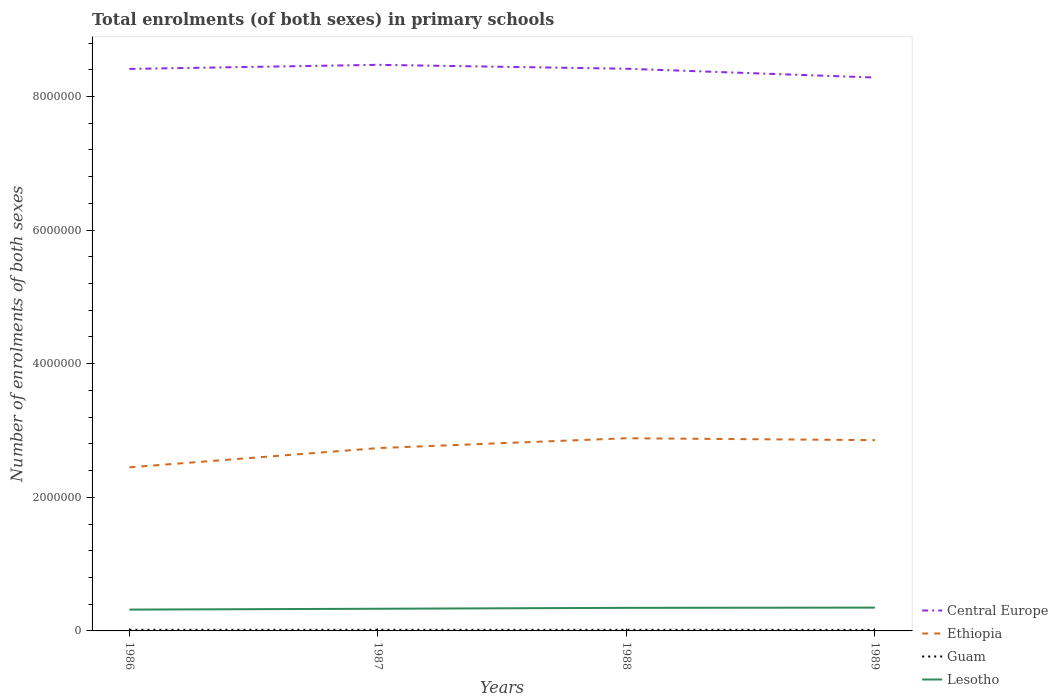Across all years, what is the maximum number of enrolments in primary schools in Lesotho?
Your response must be concise. 3.19e+05. What is the total number of enrolments in primary schools in Ethiopia in the graph?
Your response must be concise. -1.48e+05. What is the difference between the highest and the second highest number of enrolments in primary schools in Guam?
Your answer should be compact. 1267. What is the difference between the highest and the lowest number of enrolments in primary schools in Lesotho?
Your answer should be very brief. 2. How many years are there in the graph?
Ensure brevity in your answer.  4. What is the difference between two consecutive major ticks on the Y-axis?
Your answer should be compact. 2.00e+06. Are the values on the major ticks of Y-axis written in scientific E-notation?
Keep it short and to the point. No. Does the graph contain grids?
Give a very brief answer. No. How many legend labels are there?
Your answer should be compact. 4. What is the title of the graph?
Keep it short and to the point. Total enrolments (of both sexes) in primary schools. What is the label or title of the X-axis?
Ensure brevity in your answer.  Years. What is the label or title of the Y-axis?
Offer a very short reply. Number of enrolments of both sexes. What is the Number of enrolments of both sexes in Central Europe in 1986?
Offer a terse response. 8.41e+06. What is the Number of enrolments of both sexes in Ethiopia in 1986?
Give a very brief answer. 2.45e+06. What is the Number of enrolments of both sexes in Guam in 1986?
Make the answer very short. 1.68e+04. What is the Number of enrolments of both sexes of Lesotho in 1986?
Make the answer very short. 3.19e+05. What is the Number of enrolments of both sexes of Central Europe in 1987?
Provide a succinct answer. 8.47e+06. What is the Number of enrolments of both sexes of Ethiopia in 1987?
Make the answer very short. 2.74e+06. What is the Number of enrolments of both sexes in Guam in 1987?
Your answer should be very brief. 1.67e+04. What is the Number of enrolments of both sexes in Lesotho in 1987?
Offer a very short reply. 3.32e+05. What is the Number of enrolments of both sexes in Central Europe in 1988?
Your answer should be very brief. 8.41e+06. What is the Number of enrolments of both sexes of Ethiopia in 1988?
Make the answer very short. 2.88e+06. What is the Number of enrolments of both sexes in Guam in 1988?
Provide a short and direct response. 1.67e+04. What is the Number of enrolments of both sexes of Lesotho in 1988?
Your answer should be compact. 3.46e+05. What is the Number of enrolments of both sexes of Central Europe in 1989?
Offer a terse response. 8.28e+06. What is the Number of enrolments of both sexes in Ethiopia in 1989?
Make the answer very short. 2.86e+06. What is the Number of enrolments of both sexes of Guam in 1989?
Provide a succinct answer. 1.55e+04. What is the Number of enrolments of both sexes of Lesotho in 1989?
Your response must be concise. 3.49e+05. Across all years, what is the maximum Number of enrolments of both sexes of Central Europe?
Ensure brevity in your answer.  8.47e+06. Across all years, what is the maximum Number of enrolments of both sexes of Ethiopia?
Keep it short and to the point. 2.88e+06. Across all years, what is the maximum Number of enrolments of both sexes of Guam?
Your answer should be very brief. 1.68e+04. Across all years, what is the maximum Number of enrolments of both sexes of Lesotho?
Keep it short and to the point. 3.49e+05. Across all years, what is the minimum Number of enrolments of both sexes of Central Europe?
Offer a terse response. 8.28e+06. Across all years, what is the minimum Number of enrolments of both sexes of Ethiopia?
Keep it short and to the point. 2.45e+06. Across all years, what is the minimum Number of enrolments of both sexes of Guam?
Your answer should be compact. 1.55e+04. Across all years, what is the minimum Number of enrolments of both sexes in Lesotho?
Offer a terse response. 3.19e+05. What is the total Number of enrolments of both sexes in Central Europe in the graph?
Ensure brevity in your answer.  3.36e+07. What is the total Number of enrolments of both sexes in Ethiopia in the graph?
Make the answer very short. 1.09e+07. What is the total Number of enrolments of both sexes in Guam in the graph?
Ensure brevity in your answer.  6.57e+04. What is the total Number of enrolments of both sexes in Lesotho in the graph?
Offer a very short reply. 1.35e+06. What is the difference between the Number of enrolments of both sexes of Central Europe in 1986 and that in 1987?
Your answer should be compact. -6.10e+04. What is the difference between the Number of enrolments of both sexes in Ethiopia in 1986 and that in 1987?
Your answer should be very brief. -2.88e+05. What is the difference between the Number of enrolments of both sexes of Guam in 1986 and that in 1987?
Make the answer very short. 50. What is the difference between the Number of enrolments of both sexes of Lesotho in 1986 and that in 1987?
Your response must be concise. -1.27e+04. What is the difference between the Number of enrolments of both sexes of Central Europe in 1986 and that in 1988?
Give a very brief answer. -2541. What is the difference between the Number of enrolments of both sexes of Ethiopia in 1986 and that in 1988?
Provide a succinct answer. -4.35e+05. What is the difference between the Number of enrolments of both sexes of Guam in 1986 and that in 1988?
Provide a succinct answer. 123. What is the difference between the Number of enrolments of both sexes in Lesotho in 1986 and that in 1988?
Provide a short and direct response. -2.64e+04. What is the difference between the Number of enrolments of both sexes of Central Europe in 1986 and that in 1989?
Ensure brevity in your answer.  1.29e+05. What is the difference between the Number of enrolments of both sexes of Ethiopia in 1986 and that in 1989?
Provide a short and direct response. -4.07e+05. What is the difference between the Number of enrolments of both sexes in Guam in 1986 and that in 1989?
Offer a very short reply. 1267. What is the difference between the Number of enrolments of both sexes in Lesotho in 1986 and that in 1989?
Keep it short and to the point. -2.97e+04. What is the difference between the Number of enrolments of both sexes of Central Europe in 1987 and that in 1988?
Ensure brevity in your answer.  5.85e+04. What is the difference between the Number of enrolments of both sexes of Ethiopia in 1987 and that in 1988?
Your response must be concise. -1.48e+05. What is the difference between the Number of enrolments of both sexes in Lesotho in 1987 and that in 1988?
Your answer should be compact. -1.37e+04. What is the difference between the Number of enrolments of both sexes in Central Europe in 1987 and that in 1989?
Your response must be concise. 1.90e+05. What is the difference between the Number of enrolments of both sexes in Ethiopia in 1987 and that in 1989?
Provide a short and direct response. -1.19e+05. What is the difference between the Number of enrolments of both sexes in Guam in 1987 and that in 1989?
Your answer should be compact. 1217. What is the difference between the Number of enrolments of both sexes in Lesotho in 1987 and that in 1989?
Your answer should be very brief. -1.70e+04. What is the difference between the Number of enrolments of both sexes in Central Europe in 1988 and that in 1989?
Offer a very short reply. 1.32e+05. What is the difference between the Number of enrolments of both sexes of Ethiopia in 1988 and that in 1989?
Ensure brevity in your answer.  2.82e+04. What is the difference between the Number of enrolments of both sexes in Guam in 1988 and that in 1989?
Give a very brief answer. 1144. What is the difference between the Number of enrolments of both sexes in Lesotho in 1988 and that in 1989?
Provide a short and direct response. -3294. What is the difference between the Number of enrolments of both sexes of Central Europe in 1986 and the Number of enrolments of both sexes of Ethiopia in 1987?
Provide a succinct answer. 5.68e+06. What is the difference between the Number of enrolments of both sexes in Central Europe in 1986 and the Number of enrolments of both sexes in Guam in 1987?
Keep it short and to the point. 8.40e+06. What is the difference between the Number of enrolments of both sexes of Central Europe in 1986 and the Number of enrolments of both sexes of Lesotho in 1987?
Your answer should be compact. 8.08e+06. What is the difference between the Number of enrolments of both sexes in Ethiopia in 1986 and the Number of enrolments of both sexes in Guam in 1987?
Give a very brief answer. 2.43e+06. What is the difference between the Number of enrolments of both sexes in Ethiopia in 1986 and the Number of enrolments of both sexes in Lesotho in 1987?
Your response must be concise. 2.12e+06. What is the difference between the Number of enrolments of both sexes of Guam in 1986 and the Number of enrolments of both sexes of Lesotho in 1987?
Make the answer very short. -3.15e+05. What is the difference between the Number of enrolments of both sexes in Central Europe in 1986 and the Number of enrolments of both sexes in Ethiopia in 1988?
Offer a terse response. 5.53e+06. What is the difference between the Number of enrolments of both sexes of Central Europe in 1986 and the Number of enrolments of both sexes of Guam in 1988?
Your response must be concise. 8.40e+06. What is the difference between the Number of enrolments of both sexes of Central Europe in 1986 and the Number of enrolments of both sexes of Lesotho in 1988?
Your answer should be very brief. 8.07e+06. What is the difference between the Number of enrolments of both sexes in Ethiopia in 1986 and the Number of enrolments of both sexes in Guam in 1988?
Ensure brevity in your answer.  2.43e+06. What is the difference between the Number of enrolments of both sexes of Ethiopia in 1986 and the Number of enrolments of both sexes of Lesotho in 1988?
Provide a succinct answer. 2.10e+06. What is the difference between the Number of enrolments of both sexes in Guam in 1986 and the Number of enrolments of both sexes in Lesotho in 1988?
Ensure brevity in your answer.  -3.29e+05. What is the difference between the Number of enrolments of both sexes in Central Europe in 1986 and the Number of enrolments of both sexes in Ethiopia in 1989?
Make the answer very short. 5.56e+06. What is the difference between the Number of enrolments of both sexes of Central Europe in 1986 and the Number of enrolments of both sexes of Guam in 1989?
Offer a very short reply. 8.40e+06. What is the difference between the Number of enrolments of both sexes in Central Europe in 1986 and the Number of enrolments of both sexes in Lesotho in 1989?
Give a very brief answer. 8.06e+06. What is the difference between the Number of enrolments of both sexes of Ethiopia in 1986 and the Number of enrolments of both sexes of Guam in 1989?
Your response must be concise. 2.43e+06. What is the difference between the Number of enrolments of both sexes in Ethiopia in 1986 and the Number of enrolments of both sexes in Lesotho in 1989?
Provide a short and direct response. 2.10e+06. What is the difference between the Number of enrolments of both sexes in Guam in 1986 and the Number of enrolments of both sexes in Lesotho in 1989?
Your answer should be compact. -3.32e+05. What is the difference between the Number of enrolments of both sexes in Central Europe in 1987 and the Number of enrolments of both sexes in Ethiopia in 1988?
Your answer should be compact. 5.59e+06. What is the difference between the Number of enrolments of both sexes of Central Europe in 1987 and the Number of enrolments of both sexes of Guam in 1988?
Your answer should be very brief. 8.46e+06. What is the difference between the Number of enrolments of both sexes of Central Europe in 1987 and the Number of enrolments of both sexes of Lesotho in 1988?
Offer a terse response. 8.13e+06. What is the difference between the Number of enrolments of both sexes of Ethiopia in 1987 and the Number of enrolments of both sexes of Guam in 1988?
Make the answer very short. 2.72e+06. What is the difference between the Number of enrolments of both sexes of Ethiopia in 1987 and the Number of enrolments of both sexes of Lesotho in 1988?
Your response must be concise. 2.39e+06. What is the difference between the Number of enrolments of both sexes in Guam in 1987 and the Number of enrolments of both sexes in Lesotho in 1988?
Ensure brevity in your answer.  -3.29e+05. What is the difference between the Number of enrolments of both sexes of Central Europe in 1987 and the Number of enrolments of both sexes of Ethiopia in 1989?
Offer a very short reply. 5.62e+06. What is the difference between the Number of enrolments of both sexes of Central Europe in 1987 and the Number of enrolments of both sexes of Guam in 1989?
Keep it short and to the point. 8.46e+06. What is the difference between the Number of enrolments of both sexes in Central Europe in 1987 and the Number of enrolments of both sexes in Lesotho in 1989?
Provide a succinct answer. 8.12e+06. What is the difference between the Number of enrolments of both sexes in Ethiopia in 1987 and the Number of enrolments of both sexes in Guam in 1989?
Offer a very short reply. 2.72e+06. What is the difference between the Number of enrolments of both sexes in Ethiopia in 1987 and the Number of enrolments of both sexes in Lesotho in 1989?
Make the answer very short. 2.39e+06. What is the difference between the Number of enrolments of both sexes in Guam in 1987 and the Number of enrolments of both sexes in Lesotho in 1989?
Offer a terse response. -3.32e+05. What is the difference between the Number of enrolments of both sexes of Central Europe in 1988 and the Number of enrolments of both sexes of Ethiopia in 1989?
Ensure brevity in your answer.  5.56e+06. What is the difference between the Number of enrolments of both sexes in Central Europe in 1988 and the Number of enrolments of both sexes in Guam in 1989?
Your answer should be compact. 8.40e+06. What is the difference between the Number of enrolments of both sexes in Central Europe in 1988 and the Number of enrolments of both sexes in Lesotho in 1989?
Ensure brevity in your answer.  8.07e+06. What is the difference between the Number of enrolments of both sexes of Ethiopia in 1988 and the Number of enrolments of both sexes of Guam in 1989?
Your response must be concise. 2.87e+06. What is the difference between the Number of enrolments of both sexes of Ethiopia in 1988 and the Number of enrolments of both sexes of Lesotho in 1989?
Give a very brief answer. 2.54e+06. What is the difference between the Number of enrolments of both sexes of Guam in 1988 and the Number of enrolments of both sexes of Lesotho in 1989?
Offer a very short reply. -3.32e+05. What is the average Number of enrolments of both sexes in Central Europe per year?
Offer a very short reply. 8.40e+06. What is the average Number of enrolments of both sexes in Ethiopia per year?
Give a very brief answer. 2.73e+06. What is the average Number of enrolments of both sexes in Guam per year?
Ensure brevity in your answer.  1.64e+04. What is the average Number of enrolments of both sexes in Lesotho per year?
Ensure brevity in your answer.  3.36e+05. In the year 1986, what is the difference between the Number of enrolments of both sexes of Central Europe and Number of enrolments of both sexes of Ethiopia?
Make the answer very short. 5.96e+06. In the year 1986, what is the difference between the Number of enrolments of both sexes in Central Europe and Number of enrolments of both sexes in Guam?
Your answer should be compact. 8.40e+06. In the year 1986, what is the difference between the Number of enrolments of both sexes in Central Europe and Number of enrolments of both sexes in Lesotho?
Keep it short and to the point. 8.09e+06. In the year 1986, what is the difference between the Number of enrolments of both sexes of Ethiopia and Number of enrolments of both sexes of Guam?
Your answer should be very brief. 2.43e+06. In the year 1986, what is the difference between the Number of enrolments of both sexes of Ethiopia and Number of enrolments of both sexes of Lesotho?
Ensure brevity in your answer.  2.13e+06. In the year 1986, what is the difference between the Number of enrolments of both sexes in Guam and Number of enrolments of both sexes in Lesotho?
Offer a very short reply. -3.02e+05. In the year 1987, what is the difference between the Number of enrolments of both sexes of Central Europe and Number of enrolments of both sexes of Ethiopia?
Offer a very short reply. 5.74e+06. In the year 1987, what is the difference between the Number of enrolments of both sexes of Central Europe and Number of enrolments of both sexes of Guam?
Ensure brevity in your answer.  8.46e+06. In the year 1987, what is the difference between the Number of enrolments of both sexes in Central Europe and Number of enrolments of both sexes in Lesotho?
Your response must be concise. 8.14e+06. In the year 1987, what is the difference between the Number of enrolments of both sexes of Ethiopia and Number of enrolments of both sexes of Guam?
Offer a very short reply. 2.72e+06. In the year 1987, what is the difference between the Number of enrolments of both sexes of Ethiopia and Number of enrolments of both sexes of Lesotho?
Your answer should be very brief. 2.40e+06. In the year 1987, what is the difference between the Number of enrolments of both sexes of Guam and Number of enrolments of both sexes of Lesotho?
Ensure brevity in your answer.  -3.15e+05. In the year 1988, what is the difference between the Number of enrolments of both sexes of Central Europe and Number of enrolments of both sexes of Ethiopia?
Ensure brevity in your answer.  5.53e+06. In the year 1988, what is the difference between the Number of enrolments of both sexes of Central Europe and Number of enrolments of both sexes of Guam?
Offer a very short reply. 8.40e+06. In the year 1988, what is the difference between the Number of enrolments of both sexes of Central Europe and Number of enrolments of both sexes of Lesotho?
Offer a terse response. 8.07e+06. In the year 1988, what is the difference between the Number of enrolments of both sexes in Ethiopia and Number of enrolments of both sexes in Guam?
Offer a terse response. 2.87e+06. In the year 1988, what is the difference between the Number of enrolments of both sexes in Ethiopia and Number of enrolments of both sexes in Lesotho?
Make the answer very short. 2.54e+06. In the year 1988, what is the difference between the Number of enrolments of both sexes of Guam and Number of enrolments of both sexes of Lesotho?
Your answer should be very brief. -3.29e+05. In the year 1989, what is the difference between the Number of enrolments of both sexes of Central Europe and Number of enrolments of both sexes of Ethiopia?
Make the answer very short. 5.43e+06. In the year 1989, what is the difference between the Number of enrolments of both sexes in Central Europe and Number of enrolments of both sexes in Guam?
Your answer should be very brief. 8.27e+06. In the year 1989, what is the difference between the Number of enrolments of both sexes of Central Europe and Number of enrolments of both sexes of Lesotho?
Provide a short and direct response. 7.93e+06. In the year 1989, what is the difference between the Number of enrolments of both sexes in Ethiopia and Number of enrolments of both sexes in Guam?
Keep it short and to the point. 2.84e+06. In the year 1989, what is the difference between the Number of enrolments of both sexes in Ethiopia and Number of enrolments of both sexes in Lesotho?
Give a very brief answer. 2.51e+06. In the year 1989, what is the difference between the Number of enrolments of both sexes in Guam and Number of enrolments of both sexes in Lesotho?
Keep it short and to the point. -3.33e+05. What is the ratio of the Number of enrolments of both sexes in Central Europe in 1986 to that in 1987?
Give a very brief answer. 0.99. What is the ratio of the Number of enrolments of both sexes of Ethiopia in 1986 to that in 1987?
Offer a terse response. 0.89. What is the ratio of the Number of enrolments of both sexes in Lesotho in 1986 to that in 1987?
Offer a very short reply. 0.96. What is the ratio of the Number of enrolments of both sexes of Ethiopia in 1986 to that in 1988?
Offer a terse response. 0.85. What is the ratio of the Number of enrolments of both sexes of Guam in 1986 to that in 1988?
Give a very brief answer. 1.01. What is the ratio of the Number of enrolments of both sexes in Lesotho in 1986 to that in 1988?
Provide a succinct answer. 0.92. What is the ratio of the Number of enrolments of both sexes of Central Europe in 1986 to that in 1989?
Offer a terse response. 1.02. What is the ratio of the Number of enrolments of both sexes in Ethiopia in 1986 to that in 1989?
Your answer should be compact. 0.86. What is the ratio of the Number of enrolments of both sexes of Guam in 1986 to that in 1989?
Provide a short and direct response. 1.08. What is the ratio of the Number of enrolments of both sexes of Lesotho in 1986 to that in 1989?
Your answer should be compact. 0.91. What is the ratio of the Number of enrolments of both sexes in Ethiopia in 1987 to that in 1988?
Offer a very short reply. 0.95. What is the ratio of the Number of enrolments of both sexes of Lesotho in 1987 to that in 1988?
Your answer should be compact. 0.96. What is the ratio of the Number of enrolments of both sexes of Central Europe in 1987 to that in 1989?
Make the answer very short. 1.02. What is the ratio of the Number of enrolments of both sexes in Ethiopia in 1987 to that in 1989?
Make the answer very short. 0.96. What is the ratio of the Number of enrolments of both sexes of Guam in 1987 to that in 1989?
Make the answer very short. 1.08. What is the ratio of the Number of enrolments of both sexes of Lesotho in 1987 to that in 1989?
Offer a very short reply. 0.95. What is the ratio of the Number of enrolments of both sexes of Central Europe in 1988 to that in 1989?
Provide a short and direct response. 1.02. What is the ratio of the Number of enrolments of both sexes in Ethiopia in 1988 to that in 1989?
Offer a very short reply. 1.01. What is the ratio of the Number of enrolments of both sexes in Guam in 1988 to that in 1989?
Give a very brief answer. 1.07. What is the ratio of the Number of enrolments of both sexes in Lesotho in 1988 to that in 1989?
Your answer should be compact. 0.99. What is the difference between the highest and the second highest Number of enrolments of both sexes of Central Europe?
Ensure brevity in your answer.  5.85e+04. What is the difference between the highest and the second highest Number of enrolments of both sexes of Ethiopia?
Provide a succinct answer. 2.82e+04. What is the difference between the highest and the second highest Number of enrolments of both sexes in Lesotho?
Provide a succinct answer. 3294. What is the difference between the highest and the lowest Number of enrolments of both sexes in Central Europe?
Give a very brief answer. 1.90e+05. What is the difference between the highest and the lowest Number of enrolments of both sexes in Ethiopia?
Offer a terse response. 4.35e+05. What is the difference between the highest and the lowest Number of enrolments of both sexes of Guam?
Make the answer very short. 1267. What is the difference between the highest and the lowest Number of enrolments of both sexes of Lesotho?
Keep it short and to the point. 2.97e+04. 